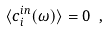Convert formula to latex. <formula><loc_0><loc_0><loc_500><loc_500>\langle c _ { i } ^ { i n } ( \omega ) \rangle = 0 \ ,</formula> 